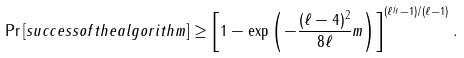Convert formula to latex. <formula><loc_0><loc_0><loc_500><loc_500>\Pr \left [ s u c c e s s o f t h e a l g o r i t h m \right ] \geq \left [ 1 - \exp \left ( - \frac { ( \ell - 4 ) ^ { 2 } } { 8 \ell } m \right ) \right ] ^ { ( \ell ^ { j _ { f } } - 1 ) / ( \ell - 1 ) } .</formula> 